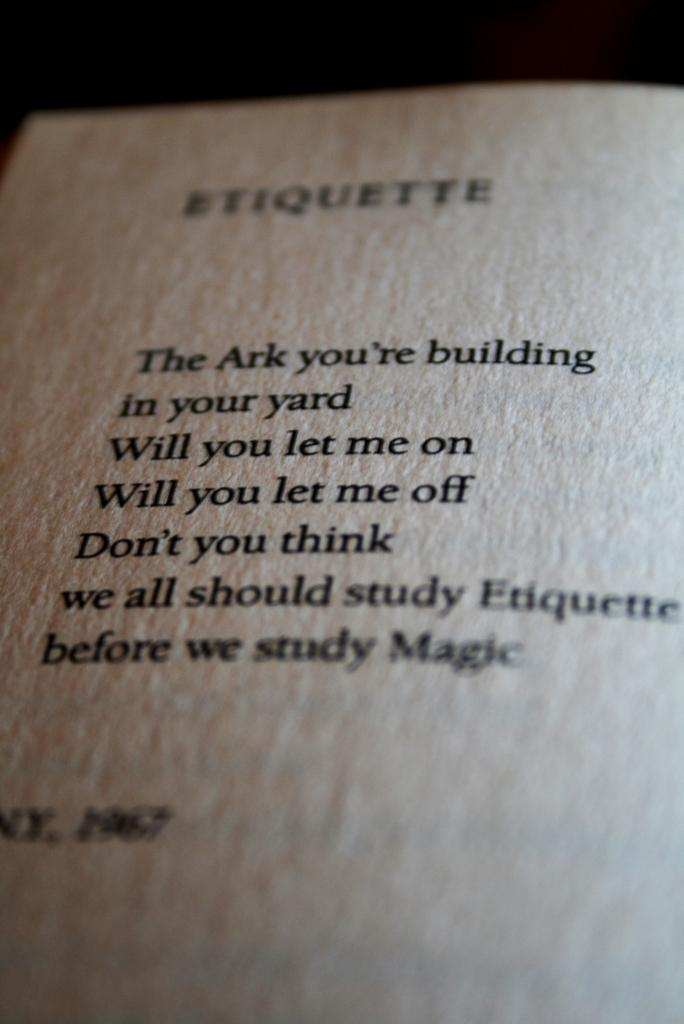Provide a one-sentence caption for the provided image. A page from a book with the title Etiquette and some sentences beneath. 